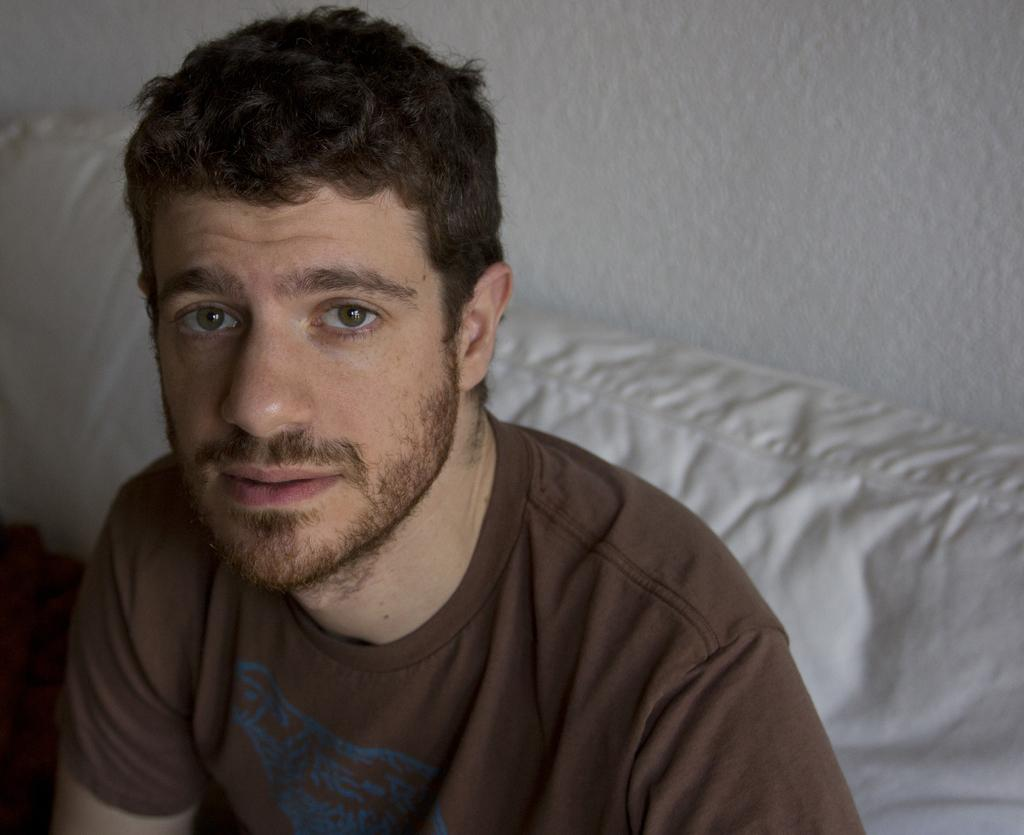Who is present in the image? There is a man in the image. What is the man doing in the image? The man is looking to his side. What is the man wearing in the image? The man is wearing a chocolate color t-shirt. What can be seen in the background of the image? There is a wall in the image. What type of leather material is the man holding in the image? There is no leather material present in the image. 